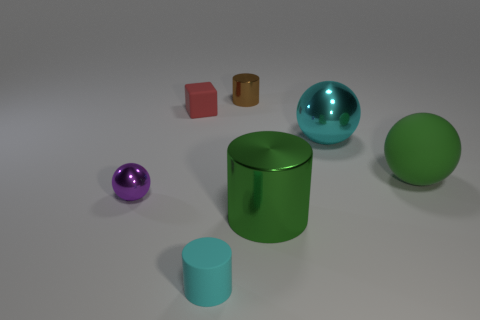Is the color of the cube the same as the tiny shiny object that is on the right side of the small cyan rubber object?
Offer a very short reply. No. There is a big thing that is the same color as the matte cylinder; what shape is it?
Your answer should be very brief. Sphere. There is a tiny thing that is to the right of the matte object in front of the metallic object in front of the purple sphere; what is its material?
Offer a very short reply. Metal. Does the matte thing to the right of the brown metal cylinder have the same shape as the purple shiny object?
Your response must be concise. Yes. What is the cyan thing that is behind the cyan rubber cylinder made of?
Make the answer very short. Metal. How many metal things are tiny cylinders or purple spheres?
Keep it short and to the point. 2. Is there a green rubber thing of the same size as the brown cylinder?
Give a very brief answer. No. Is the number of green objects that are to the right of the purple metal ball greater than the number of big purple cylinders?
Offer a very short reply. Yes. How many large objects are either rubber cylinders or red matte objects?
Your answer should be compact. 0. How many green things have the same shape as the tiny brown metal object?
Give a very brief answer. 1. 